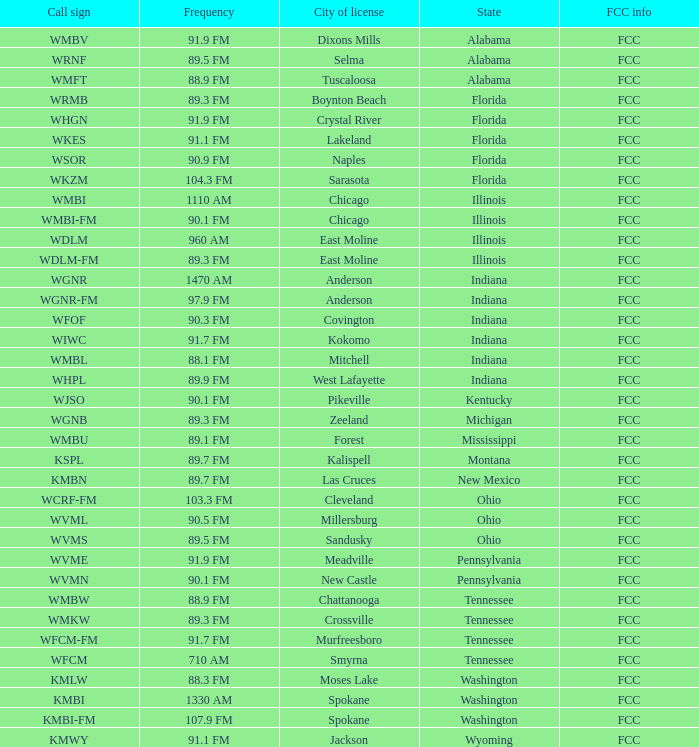3 fm permitted? Cleveland. 